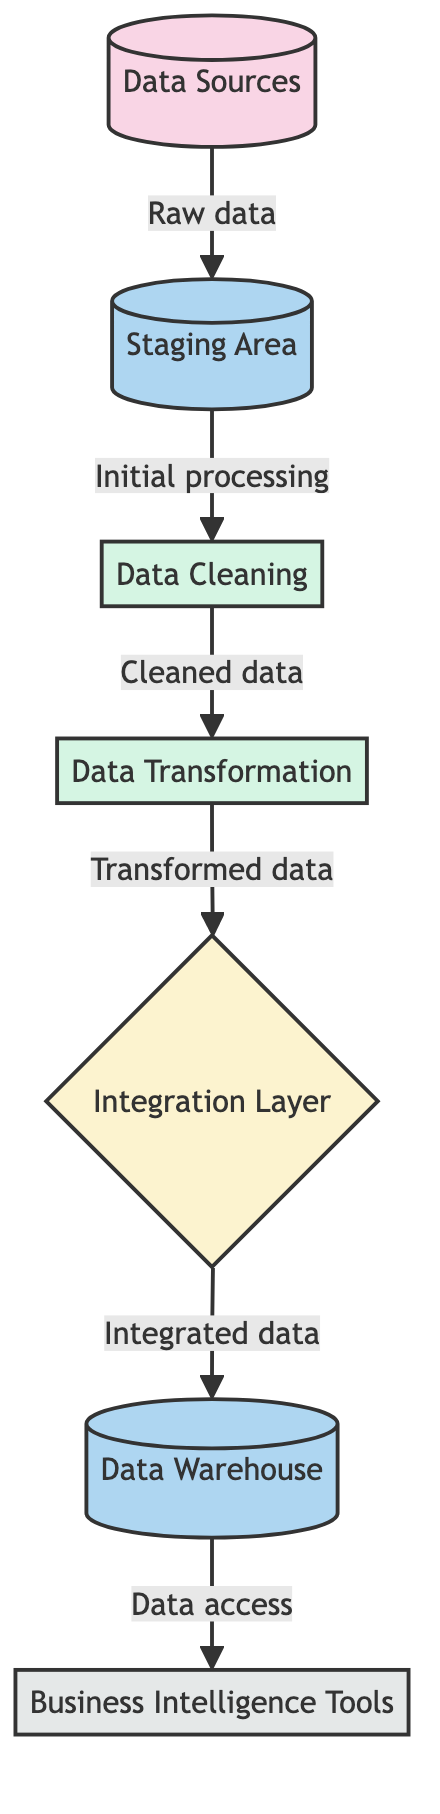What are the data sources in this diagram? The nodes labeled as data sources represent the collection of raw data from multiple systems. In the diagram, this is clearly identified as "Data Sources."
Answer: Data Sources How many nodes are there in total? Counting the elements represented in the diagram, there are seven nodes: Data Sources, Staging Area, Data Cleaning, Data Transformation, Integration Layer, Data Warehouse, and Business Intelligence Tools.
Answer: Seven What type of node is the "Data Warehouse"? The "Data Warehouse" node is categorized as a storage type. It is depicted in the diagram and described as a central repository of integrated data.
Answer: Storage Which process occurs directly after "Data Cleaning"? Following "Data Cleaning," the next step in the workflow is "Data Transformation," as indicated by the directional flow from the cleaning process to transformation.
Answer: Data Transformation What is the relationship between "Integration Layer" and "Data Warehouse"? The "Integration Layer" feeds data directly into the "Data Warehouse," represented in the diagram by the direct edge connecting the two nodes.
Answer: Integrated data How is data prepped before being loaded into the Data Warehouse? Data is first cleaned and transformed after being staged, following the connections in the diagram from "Staging Area" to "Data Cleaning," then to "Data Transformation," prior to being loaded into the "Data Warehouse."
Answer: Cleaned and transformed Which tool utilizes the data from the Data Warehouse? The "Business Intelligence Tools" are identified as the tools that access the data stored in the "Data Warehouse" for analysis and reporting.
Answer: Business Intelligence Tools What sequence of processes is followed after data enters the Staging Area? After data enters the "Staging Area," it is first transferred to "Data Cleaning," followed by "Data Transformation," according to the connection arrows in the diagram, resulting in a clear workflow sequence.
Answer: Data Cleaning, Data Transformation What does the Integration Layer do in this process? The "Integration Layer" is responsible for combining and unifying data from various sources before it is loaded into the "Data Warehouse," as shown by the flow leading into it from "Data Transformation."
Answer: Combining data 